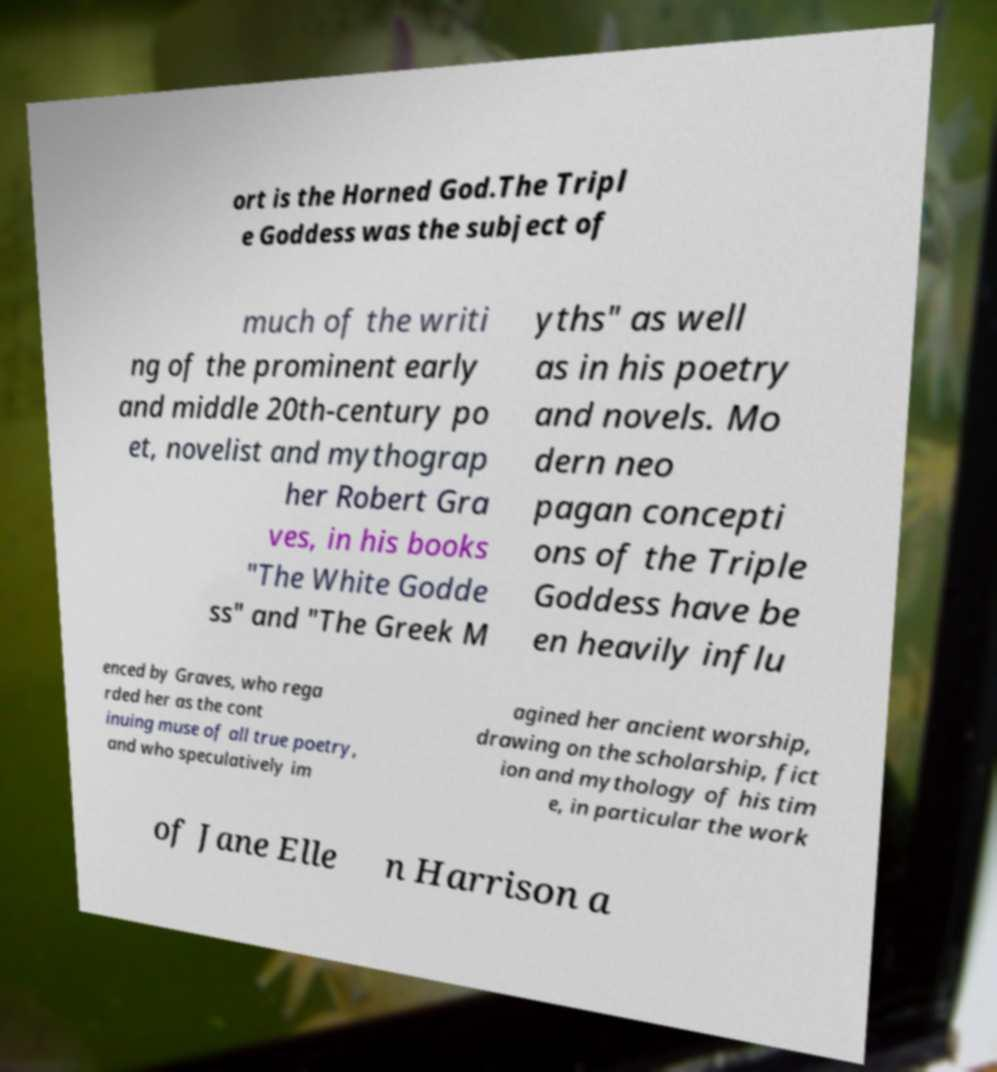What messages or text are displayed in this image? I need them in a readable, typed format. ort is the Horned God.The Tripl e Goddess was the subject of much of the writi ng of the prominent early and middle 20th-century po et, novelist and mythograp her Robert Gra ves, in his books "The White Godde ss" and "The Greek M yths" as well as in his poetry and novels. Mo dern neo pagan concepti ons of the Triple Goddess have be en heavily influ enced by Graves, who rega rded her as the cont inuing muse of all true poetry, and who speculatively im agined her ancient worship, drawing on the scholarship, fict ion and mythology of his tim e, in particular the work of Jane Elle n Harrison a 